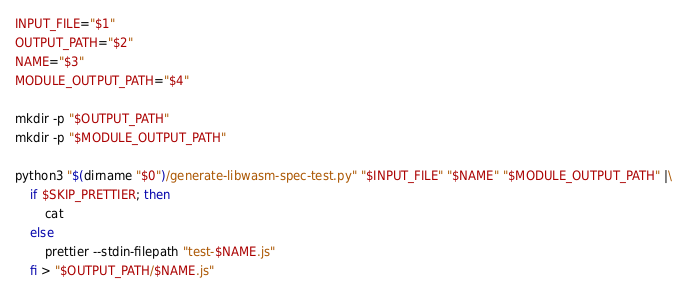<code> <loc_0><loc_0><loc_500><loc_500><_Bash_>
INPUT_FILE="$1"
OUTPUT_PATH="$2"
NAME="$3"
MODULE_OUTPUT_PATH="$4"

mkdir -p "$OUTPUT_PATH"
mkdir -p "$MODULE_OUTPUT_PATH"

python3 "$(dirname "$0")/generate-libwasm-spec-test.py" "$INPUT_FILE" "$NAME" "$MODULE_OUTPUT_PATH" |\
    if $SKIP_PRETTIER; then
        cat
    else
        prettier --stdin-filepath "test-$NAME.js"
    fi > "$OUTPUT_PATH/$NAME.js"
</code> 